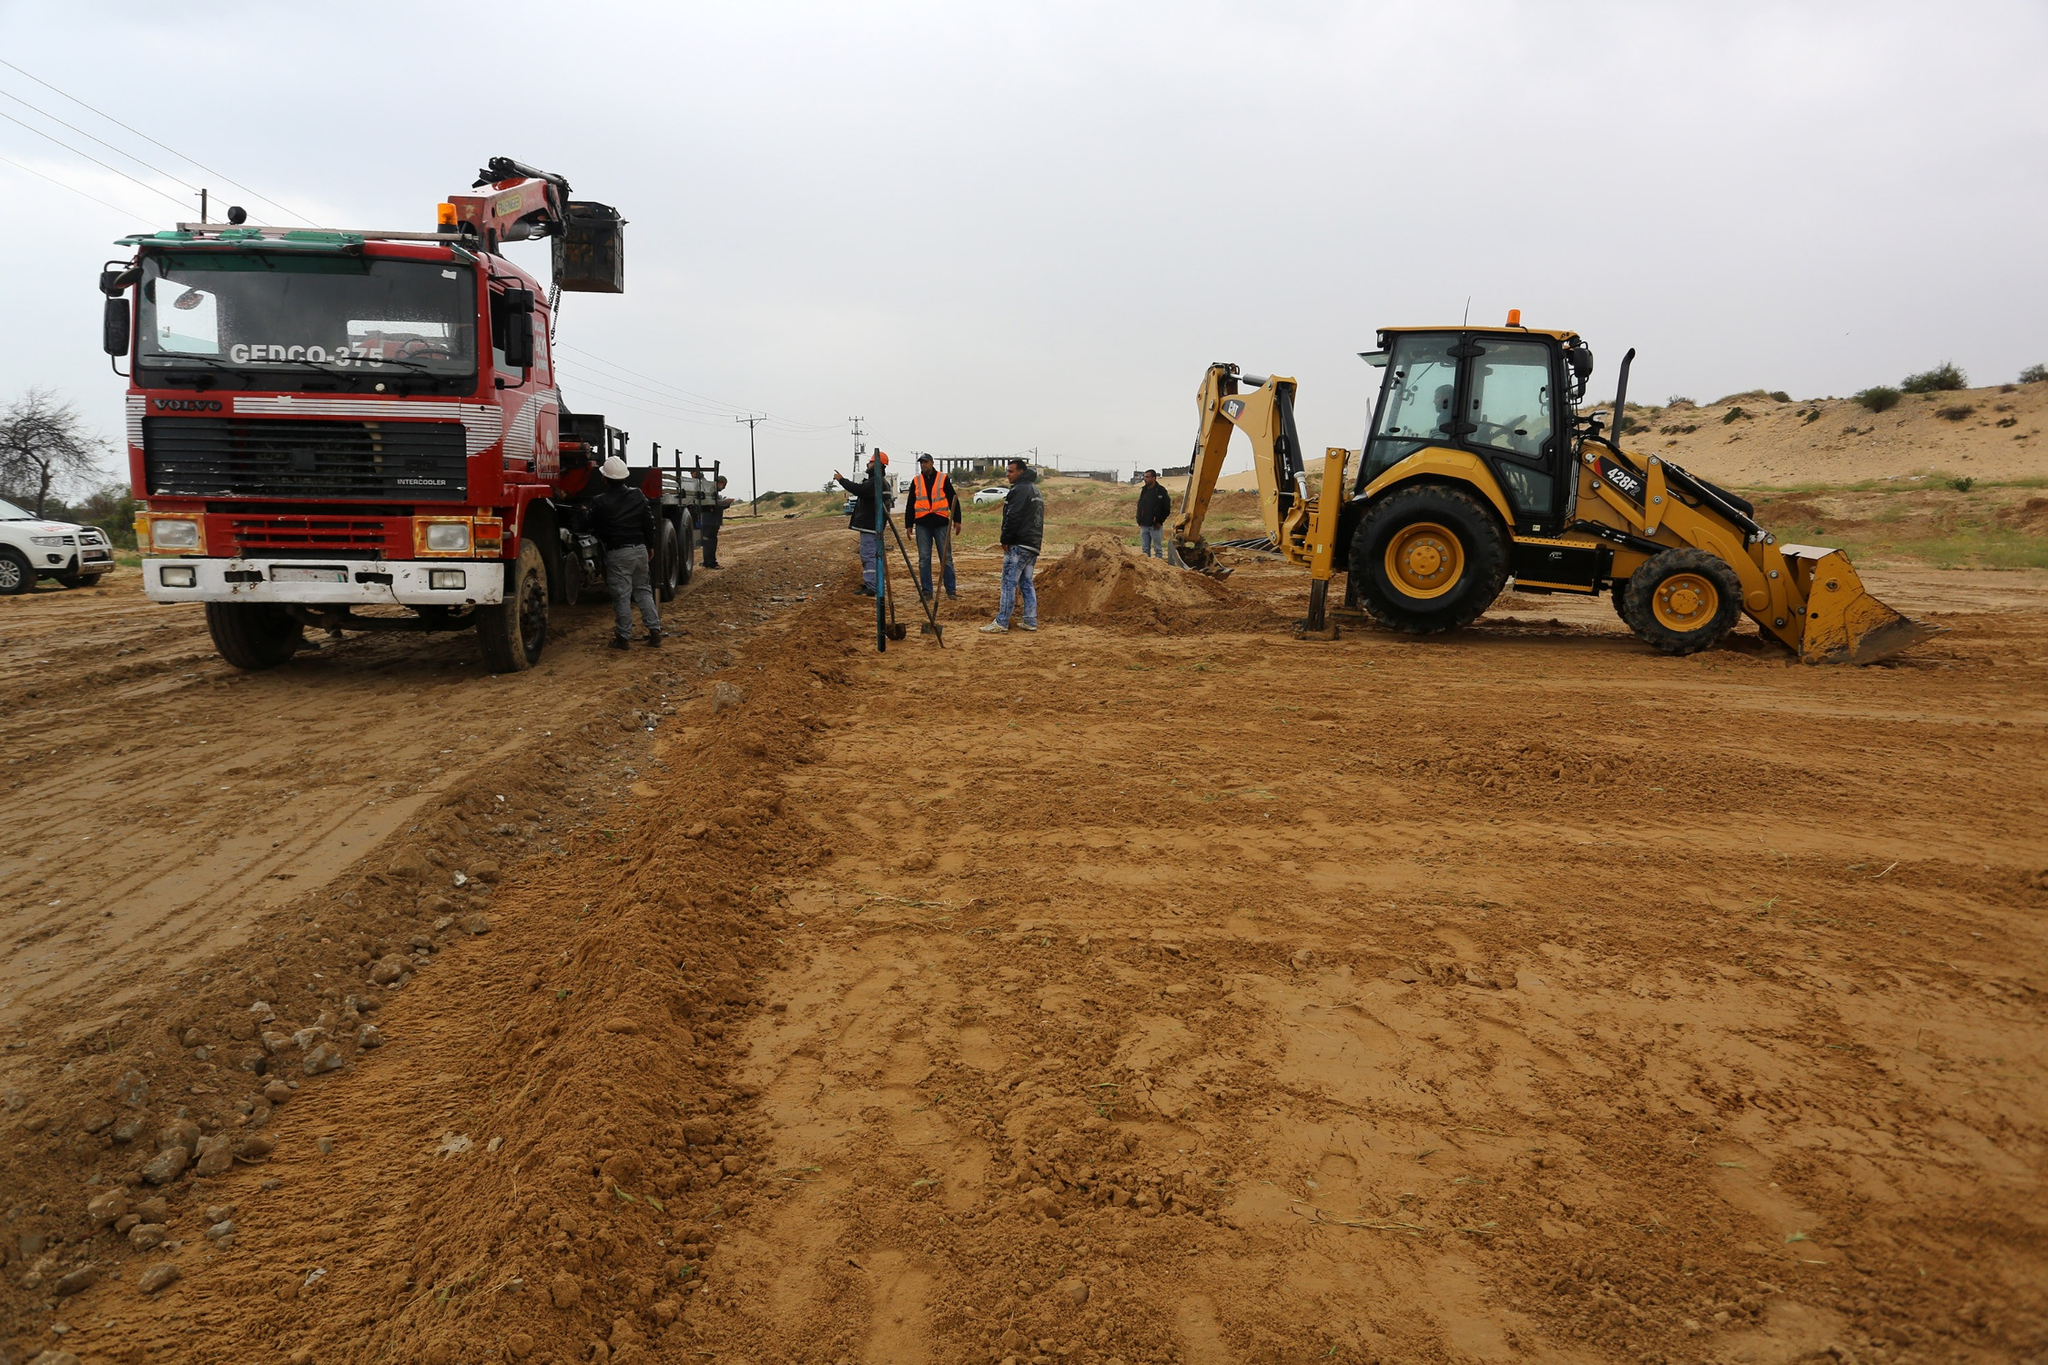What does the scene tell us about the role of technology in modern construction? The scene vividly illustrates the indispensability of technology in contemporary construction. The crane-equipped truck and bulldozer symbolize the significant leap from manual labor to mechanized processes, enhancing efficiency and precision. These machines allow for the rapid movement and manipulation of heavy materials, vastly accelerating project timelines. Furthermore, technology aids in ensuring safety, with advanced machinery reducing the need for hazardous manual tasks. Overall, it underscores how modern construction relies on technological advancements to meet the growing demands and complexities of today’s infrastructural projects. 